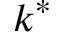Convert formula to latex. <formula><loc_0><loc_0><loc_500><loc_500>k ^ { * }</formula> 